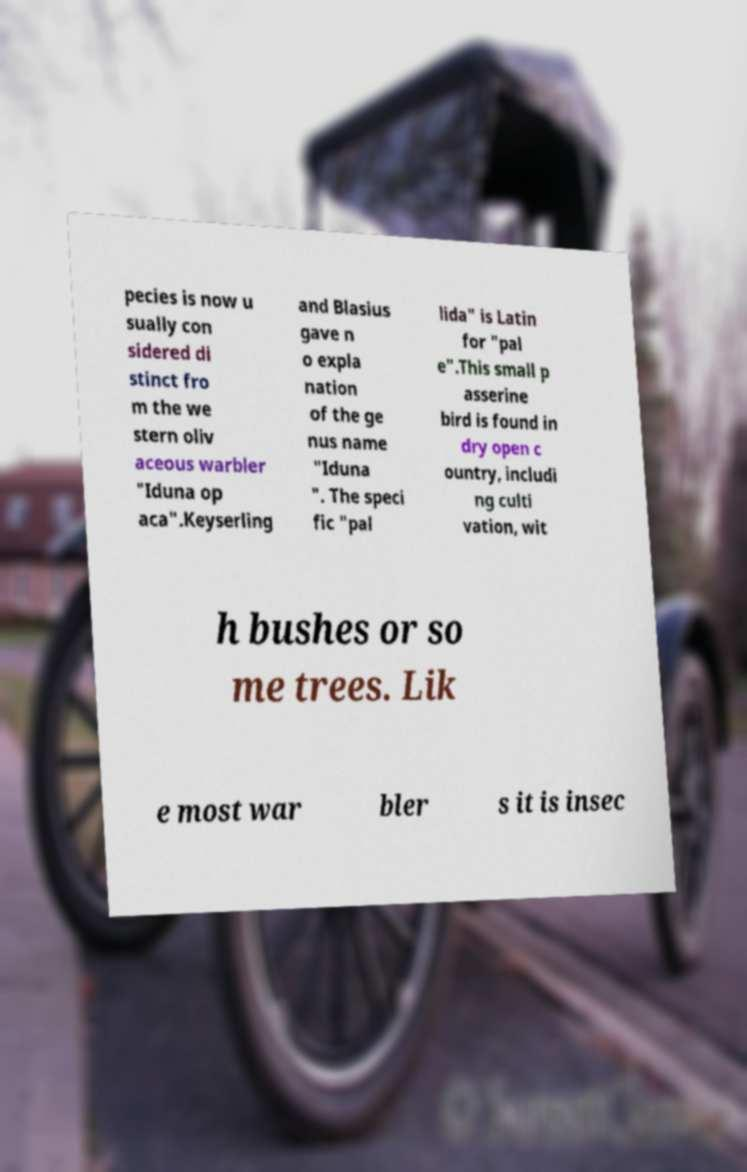Please identify and transcribe the text found in this image. pecies is now u sually con sidered di stinct fro m the we stern oliv aceous warbler "Iduna op aca".Keyserling and Blasius gave n o expla nation of the ge nus name "Iduna ". The speci fic "pal lida" is Latin for "pal e".This small p asserine bird is found in dry open c ountry, includi ng culti vation, wit h bushes or so me trees. Lik e most war bler s it is insec 